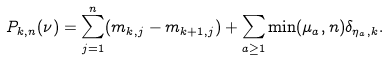Convert formula to latex. <formula><loc_0><loc_0><loc_500><loc_500>P _ { k , n } ( \nu ) = \sum _ { j = 1 } ^ { n } ( m _ { k , j } - m _ { k + 1 , j } ) + \sum _ { a \geq 1 } \min ( \mu _ { a } , n ) \delta _ { \eta _ { a } , k } .</formula> 